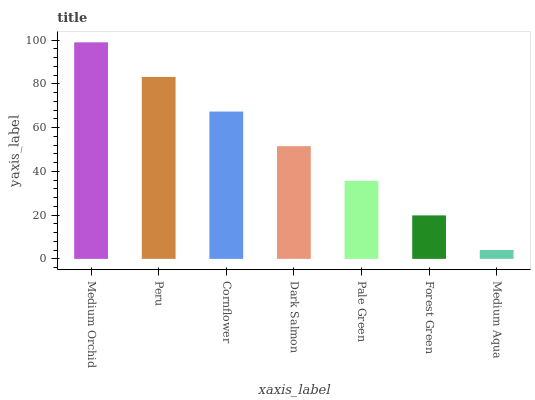Is Medium Aqua the minimum?
Answer yes or no. Yes. Is Medium Orchid the maximum?
Answer yes or no. Yes. Is Peru the minimum?
Answer yes or no. No. Is Peru the maximum?
Answer yes or no. No. Is Medium Orchid greater than Peru?
Answer yes or no. Yes. Is Peru less than Medium Orchid?
Answer yes or no. Yes. Is Peru greater than Medium Orchid?
Answer yes or no. No. Is Medium Orchid less than Peru?
Answer yes or no. No. Is Dark Salmon the high median?
Answer yes or no. Yes. Is Dark Salmon the low median?
Answer yes or no. Yes. Is Cornflower the high median?
Answer yes or no. No. Is Forest Green the low median?
Answer yes or no. No. 